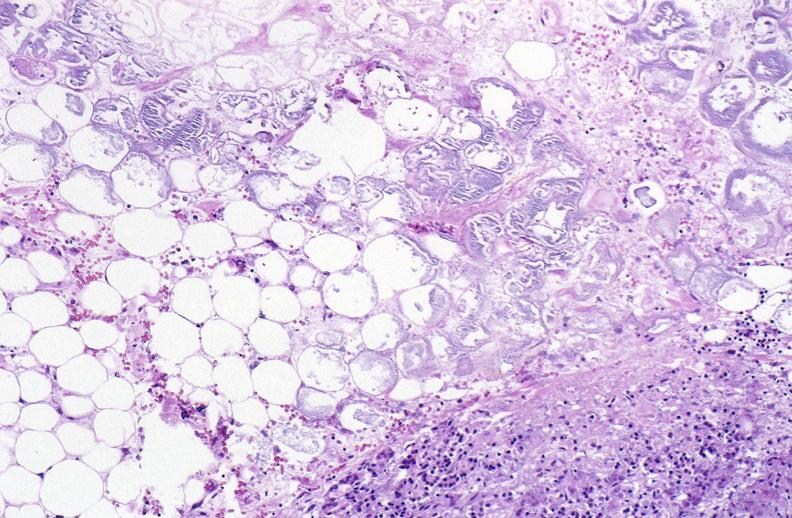where is this?
Answer the question using a single word or phrase. Pancreas 